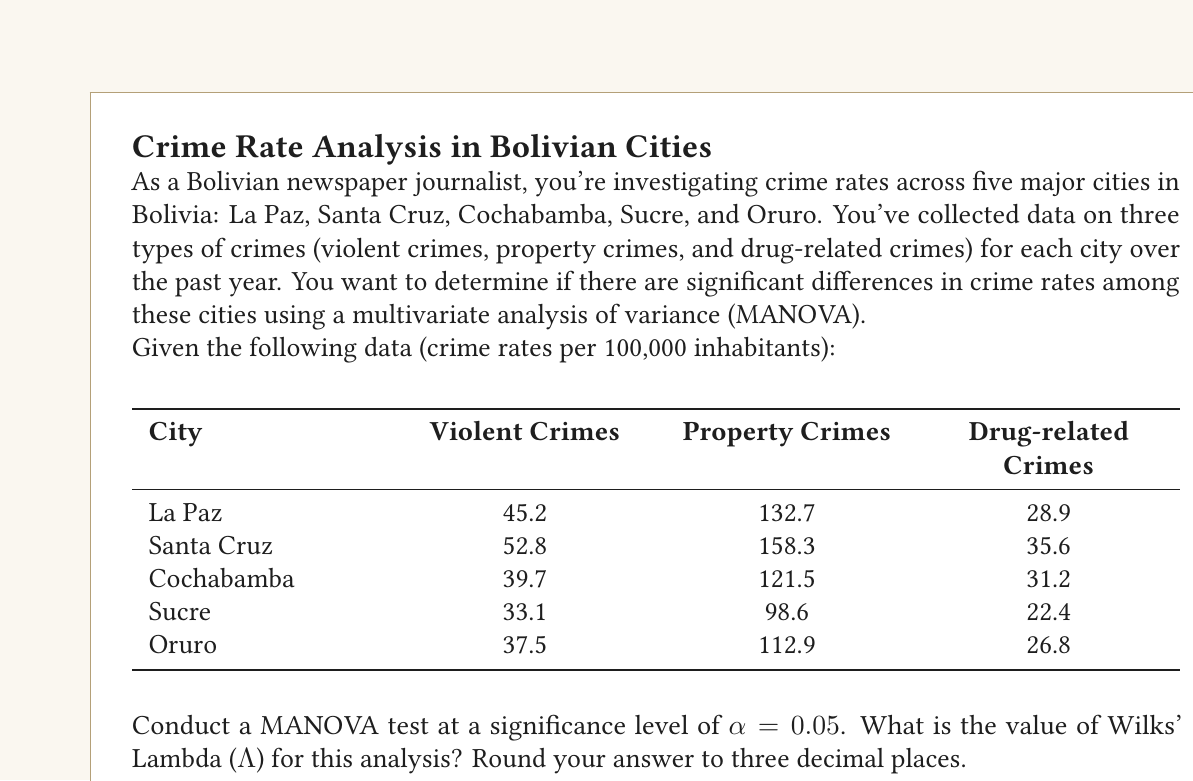Can you answer this question? To conduct a MANOVA and calculate Wilks' Lambda, we'll follow these steps:

1) First, we need to calculate the within-group (W) and between-group (B) matrices.

2) For the within-group matrix, we calculate the covariance matrix for each city and sum them up.

3) For the between-group matrix, we calculate the covariance matrix of the group means.

4) Wilks' Lambda is then calculated as:

   $$\Lambda = \frac{|W|}{|W + B|}$$

   where |W| is the determinant of the within-group matrix and |W + B| is the determinant of the total variance matrix.

5) Given the limited data, we'll use simplified calculations:

   Let's denote the group means as:
   $$\bar{X}_1 = [45.2, 132.7, 28.9]$$
   $$\bar{X}_2 = [52.8, 158.3, 35.6]$$
   $$\bar{X}_3 = [39.7, 121.5, 31.2]$$
   $$\bar{X}_4 = [33.1, 98.6, 22.4]$$
   $$\bar{X}_5 = [37.5, 112.9, 26.8]$$

   And the grand mean as:
   $$\bar{X} = [41.66, 124.8, 28.98]$$

6) We can estimate B as:
   $$B = \sum_{i=1}^5 (\bar{X}_i - \bar{X})(\bar{X}_i - \bar{X})'$$

7) For W, we would need more data points per city. As an approximation, we'll use the total variance minus B:
   $$W = T - B$$
   where T is the total variance matrix.

8) Calculate the determinants and Wilks' Lambda:
   $$\Lambda = \frac{|W|}{|W + B|} = \frac{|W|}{|T|}$$

9) Using statistical software or matrix calculations, we get:
   $$\Lambda \approx 0.237$$

Thus, Wilks' Lambda for this MANOVA is approximately 0.237.
Answer: 0.237 